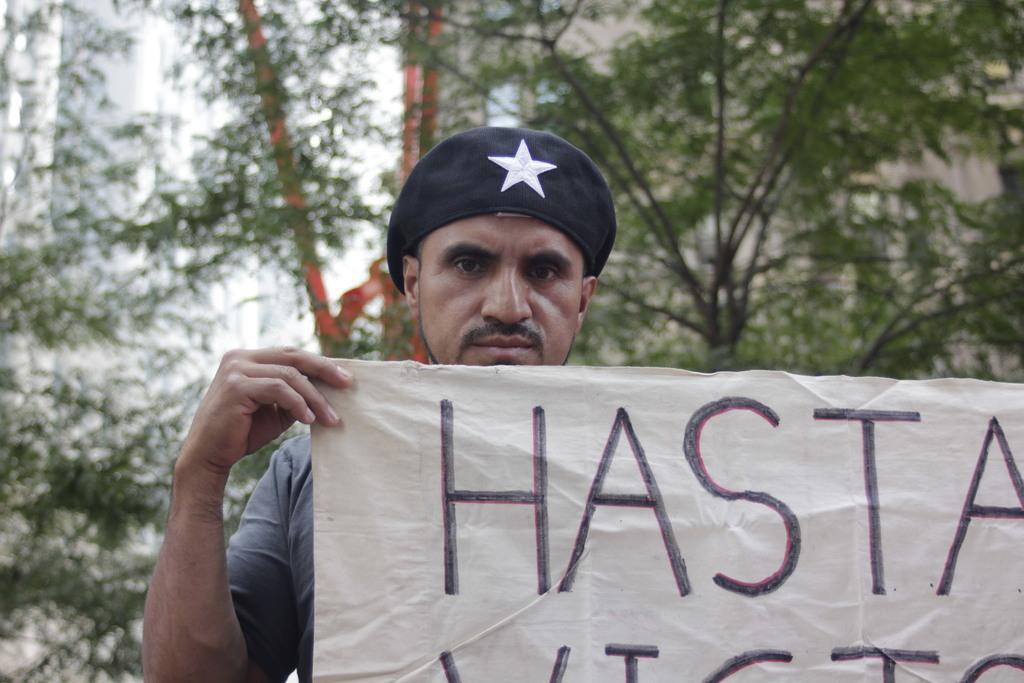Could you give a brief overview of what you see in this image? In this image we can see one man standing and holding a banner with text. There are some trees, one object behind the man, in the background it looks like buildings and the background is blurred. 